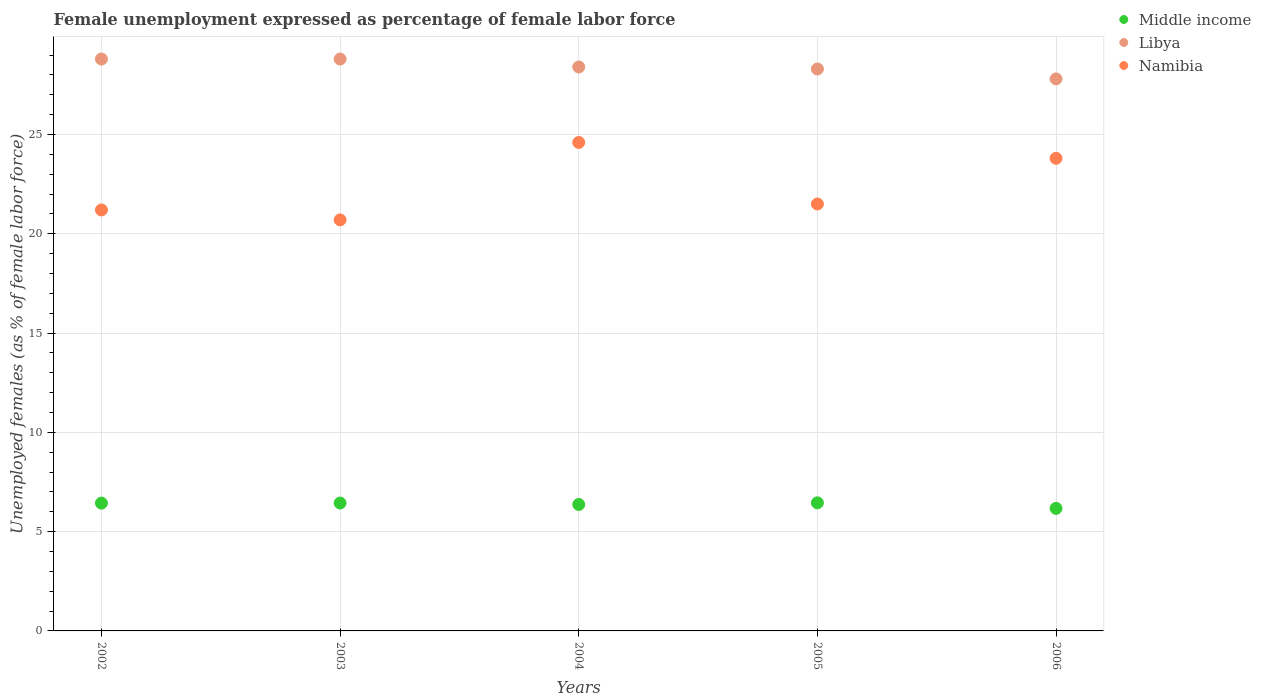How many different coloured dotlines are there?
Make the answer very short. 3. What is the unemployment in females in in Namibia in 2003?
Keep it short and to the point. 20.7. Across all years, what is the maximum unemployment in females in in Middle income?
Provide a short and direct response. 6.45. Across all years, what is the minimum unemployment in females in in Middle income?
Keep it short and to the point. 6.17. In which year was the unemployment in females in in Middle income maximum?
Offer a very short reply. 2005. In which year was the unemployment in females in in Libya minimum?
Give a very brief answer. 2006. What is the total unemployment in females in in Middle income in the graph?
Offer a terse response. 31.87. What is the difference between the unemployment in females in in Libya in 2005 and that in 2006?
Ensure brevity in your answer.  0.5. What is the difference between the unemployment in females in in Namibia in 2006 and the unemployment in females in in Middle income in 2002?
Offer a terse response. 17.36. What is the average unemployment in females in in Namibia per year?
Ensure brevity in your answer.  22.36. In the year 2003, what is the difference between the unemployment in females in in Middle income and unemployment in females in in Libya?
Provide a short and direct response. -22.36. What is the ratio of the unemployment in females in in Namibia in 2004 to that in 2005?
Give a very brief answer. 1.14. Is the unemployment in females in in Libya in 2005 less than that in 2006?
Your answer should be compact. No. Is the difference between the unemployment in females in in Middle income in 2003 and 2005 greater than the difference between the unemployment in females in in Libya in 2003 and 2005?
Ensure brevity in your answer.  No. What is the difference between the highest and the second highest unemployment in females in in Namibia?
Keep it short and to the point. 0.8. What is the difference between the highest and the lowest unemployment in females in in Middle income?
Give a very brief answer. 0.28. Is the sum of the unemployment in females in in Namibia in 2002 and 2003 greater than the maximum unemployment in females in in Middle income across all years?
Your response must be concise. Yes. Is the unemployment in females in in Namibia strictly greater than the unemployment in females in in Middle income over the years?
Your response must be concise. Yes. Is the unemployment in females in in Libya strictly less than the unemployment in females in in Namibia over the years?
Your answer should be very brief. No. How many years are there in the graph?
Your answer should be very brief. 5. What is the difference between two consecutive major ticks on the Y-axis?
Keep it short and to the point. 5. Are the values on the major ticks of Y-axis written in scientific E-notation?
Your answer should be very brief. No. Does the graph contain any zero values?
Your answer should be compact. No. Does the graph contain grids?
Your response must be concise. Yes. Where does the legend appear in the graph?
Offer a very short reply. Top right. How many legend labels are there?
Give a very brief answer. 3. What is the title of the graph?
Your answer should be compact. Female unemployment expressed as percentage of female labor force. Does "India" appear as one of the legend labels in the graph?
Your response must be concise. No. What is the label or title of the Y-axis?
Ensure brevity in your answer.  Unemployed females (as % of female labor force). What is the Unemployed females (as % of female labor force) of Middle income in 2002?
Make the answer very short. 6.44. What is the Unemployed females (as % of female labor force) in Libya in 2002?
Offer a terse response. 28.8. What is the Unemployed females (as % of female labor force) in Namibia in 2002?
Make the answer very short. 21.2. What is the Unemployed females (as % of female labor force) in Middle income in 2003?
Offer a very short reply. 6.44. What is the Unemployed females (as % of female labor force) in Libya in 2003?
Provide a succinct answer. 28.8. What is the Unemployed females (as % of female labor force) in Namibia in 2003?
Provide a succinct answer. 20.7. What is the Unemployed females (as % of female labor force) of Middle income in 2004?
Your answer should be compact. 6.37. What is the Unemployed females (as % of female labor force) of Libya in 2004?
Ensure brevity in your answer.  28.4. What is the Unemployed females (as % of female labor force) in Namibia in 2004?
Keep it short and to the point. 24.6. What is the Unemployed females (as % of female labor force) in Middle income in 2005?
Make the answer very short. 6.45. What is the Unemployed females (as % of female labor force) of Libya in 2005?
Your answer should be compact. 28.3. What is the Unemployed females (as % of female labor force) in Namibia in 2005?
Provide a succinct answer. 21.5. What is the Unemployed females (as % of female labor force) of Middle income in 2006?
Provide a short and direct response. 6.17. What is the Unemployed females (as % of female labor force) in Libya in 2006?
Make the answer very short. 27.8. What is the Unemployed females (as % of female labor force) of Namibia in 2006?
Your answer should be very brief. 23.8. Across all years, what is the maximum Unemployed females (as % of female labor force) in Middle income?
Make the answer very short. 6.45. Across all years, what is the maximum Unemployed females (as % of female labor force) in Libya?
Your response must be concise. 28.8. Across all years, what is the maximum Unemployed females (as % of female labor force) of Namibia?
Offer a terse response. 24.6. Across all years, what is the minimum Unemployed females (as % of female labor force) of Middle income?
Ensure brevity in your answer.  6.17. Across all years, what is the minimum Unemployed females (as % of female labor force) in Libya?
Keep it short and to the point. 27.8. Across all years, what is the minimum Unemployed females (as % of female labor force) of Namibia?
Offer a terse response. 20.7. What is the total Unemployed females (as % of female labor force) of Middle income in the graph?
Provide a succinct answer. 31.87. What is the total Unemployed females (as % of female labor force) in Libya in the graph?
Keep it short and to the point. 142.1. What is the total Unemployed females (as % of female labor force) in Namibia in the graph?
Offer a terse response. 111.8. What is the difference between the Unemployed females (as % of female labor force) of Middle income in 2002 and that in 2003?
Keep it short and to the point. -0. What is the difference between the Unemployed females (as % of female labor force) in Libya in 2002 and that in 2003?
Keep it short and to the point. 0. What is the difference between the Unemployed females (as % of female labor force) in Middle income in 2002 and that in 2004?
Provide a short and direct response. 0.07. What is the difference between the Unemployed females (as % of female labor force) in Libya in 2002 and that in 2004?
Offer a terse response. 0.4. What is the difference between the Unemployed females (as % of female labor force) in Namibia in 2002 and that in 2004?
Provide a short and direct response. -3.4. What is the difference between the Unemployed females (as % of female labor force) of Middle income in 2002 and that in 2005?
Offer a very short reply. -0.01. What is the difference between the Unemployed females (as % of female labor force) in Libya in 2002 and that in 2005?
Make the answer very short. 0.5. What is the difference between the Unemployed females (as % of female labor force) of Middle income in 2002 and that in 2006?
Provide a succinct answer. 0.26. What is the difference between the Unemployed females (as % of female labor force) in Namibia in 2002 and that in 2006?
Make the answer very short. -2.6. What is the difference between the Unemployed females (as % of female labor force) in Middle income in 2003 and that in 2004?
Provide a short and direct response. 0.07. What is the difference between the Unemployed females (as % of female labor force) of Libya in 2003 and that in 2004?
Provide a short and direct response. 0.4. What is the difference between the Unemployed females (as % of female labor force) in Namibia in 2003 and that in 2004?
Provide a succinct answer. -3.9. What is the difference between the Unemployed females (as % of female labor force) of Middle income in 2003 and that in 2005?
Offer a very short reply. -0.01. What is the difference between the Unemployed females (as % of female labor force) in Libya in 2003 and that in 2005?
Your answer should be very brief. 0.5. What is the difference between the Unemployed females (as % of female labor force) in Namibia in 2003 and that in 2005?
Offer a very short reply. -0.8. What is the difference between the Unemployed females (as % of female labor force) in Middle income in 2003 and that in 2006?
Give a very brief answer. 0.27. What is the difference between the Unemployed females (as % of female labor force) of Namibia in 2003 and that in 2006?
Make the answer very short. -3.1. What is the difference between the Unemployed females (as % of female labor force) of Middle income in 2004 and that in 2005?
Your answer should be very brief. -0.08. What is the difference between the Unemployed females (as % of female labor force) of Middle income in 2004 and that in 2006?
Make the answer very short. 0.2. What is the difference between the Unemployed females (as % of female labor force) in Middle income in 2005 and that in 2006?
Provide a succinct answer. 0.28. What is the difference between the Unemployed females (as % of female labor force) in Libya in 2005 and that in 2006?
Provide a short and direct response. 0.5. What is the difference between the Unemployed females (as % of female labor force) in Middle income in 2002 and the Unemployed females (as % of female labor force) in Libya in 2003?
Provide a short and direct response. -22.36. What is the difference between the Unemployed females (as % of female labor force) in Middle income in 2002 and the Unemployed females (as % of female labor force) in Namibia in 2003?
Provide a succinct answer. -14.26. What is the difference between the Unemployed females (as % of female labor force) in Middle income in 2002 and the Unemployed females (as % of female labor force) in Libya in 2004?
Your answer should be compact. -21.96. What is the difference between the Unemployed females (as % of female labor force) in Middle income in 2002 and the Unemployed females (as % of female labor force) in Namibia in 2004?
Give a very brief answer. -18.16. What is the difference between the Unemployed females (as % of female labor force) of Middle income in 2002 and the Unemployed females (as % of female labor force) of Libya in 2005?
Provide a short and direct response. -21.86. What is the difference between the Unemployed females (as % of female labor force) in Middle income in 2002 and the Unemployed females (as % of female labor force) in Namibia in 2005?
Your answer should be compact. -15.06. What is the difference between the Unemployed females (as % of female labor force) of Libya in 2002 and the Unemployed females (as % of female labor force) of Namibia in 2005?
Keep it short and to the point. 7.3. What is the difference between the Unemployed females (as % of female labor force) in Middle income in 2002 and the Unemployed females (as % of female labor force) in Libya in 2006?
Keep it short and to the point. -21.36. What is the difference between the Unemployed females (as % of female labor force) in Middle income in 2002 and the Unemployed females (as % of female labor force) in Namibia in 2006?
Offer a very short reply. -17.36. What is the difference between the Unemployed females (as % of female labor force) in Libya in 2002 and the Unemployed females (as % of female labor force) in Namibia in 2006?
Give a very brief answer. 5. What is the difference between the Unemployed females (as % of female labor force) of Middle income in 2003 and the Unemployed females (as % of female labor force) of Libya in 2004?
Make the answer very short. -21.96. What is the difference between the Unemployed females (as % of female labor force) in Middle income in 2003 and the Unemployed females (as % of female labor force) in Namibia in 2004?
Keep it short and to the point. -18.16. What is the difference between the Unemployed females (as % of female labor force) of Libya in 2003 and the Unemployed females (as % of female labor force) of Namibia in 2004?
Your answer should be very brief. 4.2. What is the difference between the Unemployed females (as % of female labor force) of Middle income in 2003 and the Unemployed females (as % of female labor force) of Libya in 2005?
Offer a terse response. -21.86. What is the difference between the Unemployed females (as % of female labor force) of Middle income in 2003 and the Unemployed females (as % of female labor force) of Namibia in 2005?
Your answer should be very brief. -15.06. What is the difference between the Unemployed females (as % of female labor force) of Middle income in 2003 and the Unemployed females (as % of female labor force) of Libya in 2006?
Provide a succinct answer. -21.36. What is the difference between the Unemployed females (as % of female labor force) in Middle income in 2003 and the Unemployed females (as % of female labor force) in Namibia in 2006?
Your answer should be very brief. -17.36. What is the difference between the Unemployed females (as % of female labor force) of Middle income in 2004 and the Unemployed females (as % of female labor force) of Libya in 2005?
Your response must be concise. -21.93. What is the difference between the Unemployed females (as % of female labor force) of Middle income in 2004 and the Unemployed females (as % of female labor force) of Namibia in 2005?
Your answer should be very brief. -15.13. What is the difference between the Unemployed females (as % of female labor force) in Middle income in 2004 and the Unemployed females (as % of female labor force) in Libya in 2006?
Ensure brevity in your answer.  -21.43. What is the difference between the Unemployed females (as % of female labor force) in Middle income in 2004 and the Unemployed females (as % of female labor force) in Namibia in 2006?
Your response must be concise. -17.43. What is the difference between the Unemployed females (as % of female labor force) of Libya in 2004 and the Unemployed females (as % of female labor force) of Namibia in 2006?
Your answer should be very brief. 4.6. What is the difference between the Unemployed females (as % of female labor force) of Middle income in 2005 and the Unemployed females (as % of female labor force) of Libya in 2006?
Your answer should be compact. -21.35. What is the difference between the Unemployed females (as % of female labor force) in Middle income in 2005 and the Unemployed females (as % of female labor force) in Namibia in 2006?
Your answer should be very brief. -17.35. What is the average Unemployed females (as % of female labor force) in Middle income per year?
Your answer should be compact. 6.37. What is the average Unemployed females (as % of female labor force) of Libya per year?
Ensure brevity in your answer.  28.42. What is the average Unemployed females (as % of female labor force) in Namibia per year?
Your answer should be compact. 22.36. In the year 2002, what is the difference between the Unemployed females (as % of female labor force) in Middle income and Unemployed females (as % of female labor force) in Libya?
Give a very brief answer. -22.36. In the year 2002, what is the difference between the Unemployed females (as % of female labor force) of Middle income and Unemployed females (as % of female labor force) of Namibia?
Provide a short and direct response. -14.76. In the year 2002, what is the difference between the Unemployed females (as % of female labor force) in Libya and Unemployed females (as % of female labor force) in Namibia?
Your answer should be very brief. 7.6. In the year 2003, what is the difference between the Unemployed females (as % of female labor force) in Middle income and Unemployed females (as % of female labor force) in Libya?
Provide a succinct answer. -22.36. In the year 2003, what is the difference between the Unemployed females (as % of female labor force) of Middle income and Unemployed females (as % of female labor force) of Namibia?
Your answer should be compact. -14.26. In the year 2004, what is the difference between the Unemployed females (as % of female labor force) in Middle income and Unemployed females (as % of female labor force) in Libya?
Provide a succinct answer. -22.03. In the year 2004, what is the difference between the Unemployed females (as % of female labor force) in Middle income and Unemployed females (as % of female labor force) in Namibia?
Provide a succinct answer. -18.23. In the year 2004, what is the difference between the Unemployed females (as % of female labor force) in Libya and Unemployed females (as % of female labor force) in Namibia?
Offer a terse response. 3.8. In the year 2005, what is the difference between the Unemployed females (as % of female labor force) of Middle income and Unemployed females (as % of female labor force) of Libya?
Ensure brevity in your answer.  -21.85. In the year 2005, what is the difference between the Unemployed females (as % of female labor force) of Middle income and Unemployed females (as % of female labor force) of Namibia?
Make the answer very short. -15.05. In the year 2005, what is the difference between the Unemployed females (as % of female labor force) in Libya and Unemployed females (as % of female labor force) in Namibia?
Make the answer very short. 6.8. In the year 2006, what is the difference between the Unemployed females (as % of female labor force) in Middle income and Unemployed females (as % of female labor force) in Libya?
Your answer should be compact. -21.63. In the year 2006, what is the difference between the Unemployed females (as % of female labor force) of Middle income and Unemployed females (as % of female labor force) of Namibia?
Offer a very short reply. -17.63. What is the ratio of the Unemployed females (as % of female labor force) in Libya in 2002 to that in 2003?
Keep it short and to the point. 1. What is the ratio of the Unemployed females (as % of female labor force) in Namibia in 2002 to that in 2003?
Make the answer very short. 1.02. What is the ratio of the Unemployed females (as % of female labor force) of Middle income in 2002 to that in 2004?
Keep it short and to the point. 1.01. What is the ratio of the Unemployed females (as % of female labor force) in Libya in 2002 to that in 2004?
Ensure brevity in your answer.  1.01. What is the ratio of the Unemployed females (as % of female labor force) in Namibia in 2002 to that in 2004?
Provide a short and direct response. 0.86. What is the ratio of the Unemployed females (as % of female labor force) in Libya in 2002 to that in 2005?
Offer a very short reply. 1.02. What is the ratio of the Unemployed females (as % of female labor force) of Middle income in 2002 to that in 2006?
Your answer should be compact. 1.04. What is the ratio of the Unemployed females (as % of female labor force) in Libya in 2002 to that in 2006?
Make the answer very short. 1.04. What is the ratio of the Unemployed females (as % of female labor force) of Namibia in 2002 to that in 2006?
Provide a short and direct response. 0.89. What is the ratio of the Unemployed females (as % of female labor force) in Middle income in 2003 to that in 2004?
Provide a succinct answer. 1.01. What is the ratio of the Unemployed females (as % of female labor force) in Libya in 2003 to that in 2004?
Provide a succinct answer. 1.01. What is the ratio of the Unemployed females (as % of female labor force) of Namibia in 2003 to that in 2004?
Your response must be concise. 0.84. What is the ratio of the Unemployed females (as % of female labor force) of Middle income in 2003 to that in 2005?
Your response must be concise. 1. What is the ratio of the Unemployed females (as % of female labor force) of Libya in 2003 to that in 2005?
Your response must be concise. 1.02. What is the ratio of the Unemployed females (as % of female labor force) of Namibia in 2003 to that in 2005?
Provide a short and direct response. 0.96. What is the ratio of the Unemployed females (as % of female labor force) of Middle income in 2003 to that in 2006?
Offer a very short reply. 1.04. What is the ratio of the Unemployed females (as % of female labor force) in Libya in 2003 to that in 2006?
Provide a short and direct response. 1.04. What is the ratio of the Unemployed females (as % of female labor force) in Namibia in 2003 to that in 2006?
Make the answer very short. 0.87. What is the ratio of the Unemployed females (as % of female labor force) in Middle income in 2004 to that in 2005?
Keep it short and to the point. 0.99. What is the ratio of the Unemployed females (as % of female labor force) of Libya in 2004 to that in 2005?
Ensure brevity in your answer.  1. What is the ratio of the Unemployed females (as % of female labor force) of Namibia in 2004 to that in 2005?
Your response must be concise. 1.14. What is the ratio of the Unemployed females (as % of female labor force) of Middle income in 2004 to that in 2006?
Your answer should be very brief. 1.03. What is the ratio of the Unemployed females (as % of female labor force) of Libya in 2004 to that in 2006?
Your answer should be very brief. 1.02. What is the ratio of the Unemployed females (as % of female labor force) in Namibia in 2004 to that in 2006?
Offer a terse response. 1.03. What is the ratio of the Unemployed females (as % of female labor force) of Middle income in 2005 to that in 2006?
Offer a terse response. 1.04. What is the ratio of the Unemployed females (as % of female labor force) in Namibia in 2005 to that in 2006?
Make the answer very short. 0.9. What is the difference between the highest and the second highest Unemployed females (as % of female labor force) in Middle income?
Give a very brief answer. 0.01. What is the difference between the highest and the second highest Unemployed females (as % of female labor force) in Libya?
Ensure brevity in your answer.  0. What is the difference between the highest and the second highest Unemployed females (as % of female labor force) of Namibia?
Provide a succinct answer. 0.8. What is the difference between the highest and the lowest Unemployed females (as % of female labor force) in Middle income?
Your response must be concise. 0.28. What is the difference between the highest and the lowest Unemployed females (as % of female labor force) of Namibia?
Your answer should be very brief. 3.9. 